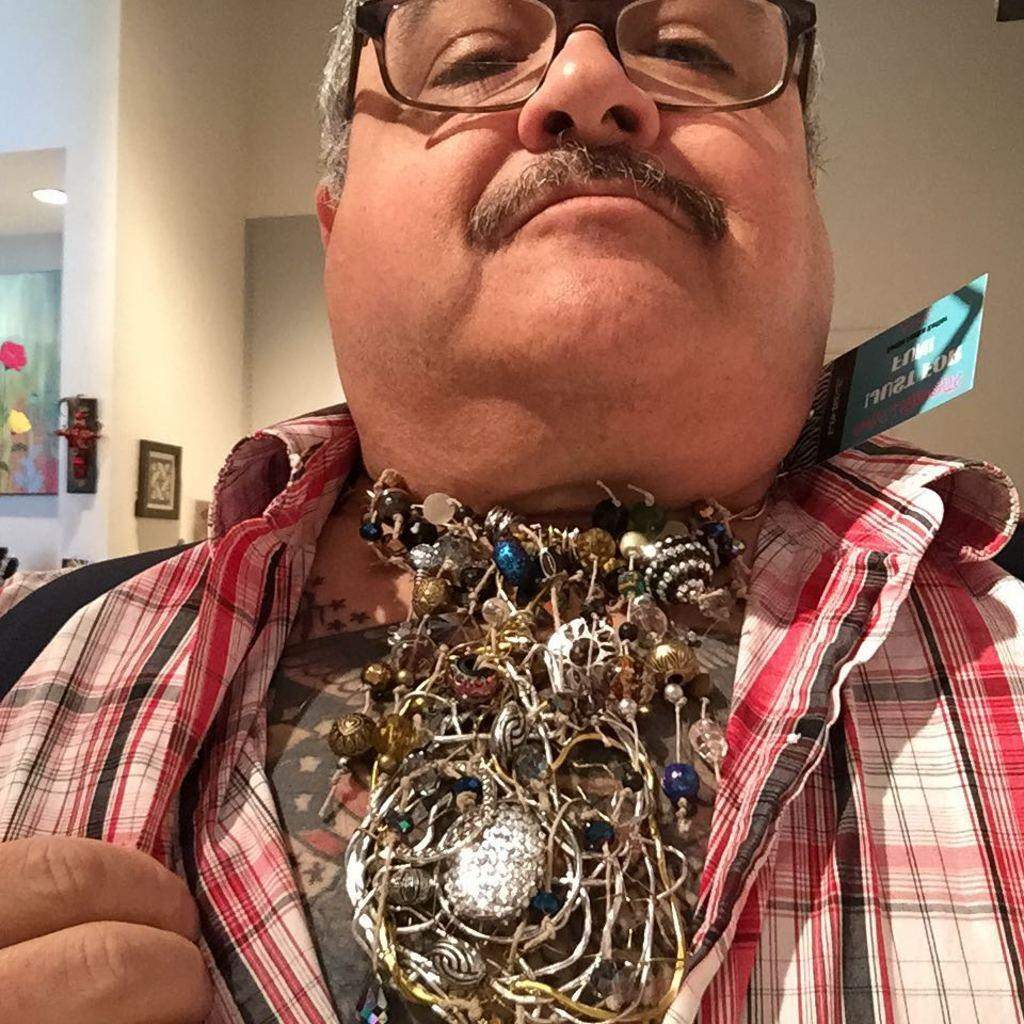Who is the main subject in the image? There is a person in the center of the image. What accessories is the person wearing? The person is wearing glasses and chains. What is the person carrying in the image? The person is carrying a bag. What can be seen on the wall in the background? There are frames placed on the wall in the background. What is the source of light in the background? There is a light in the background. What type of wound can be seen on the person's teeth in the image? There is no wound visible on the person's teeth in the image, as the person is wearing glasses and chains, carrying a bag, and there is no mention of teeth in the provided facts. 